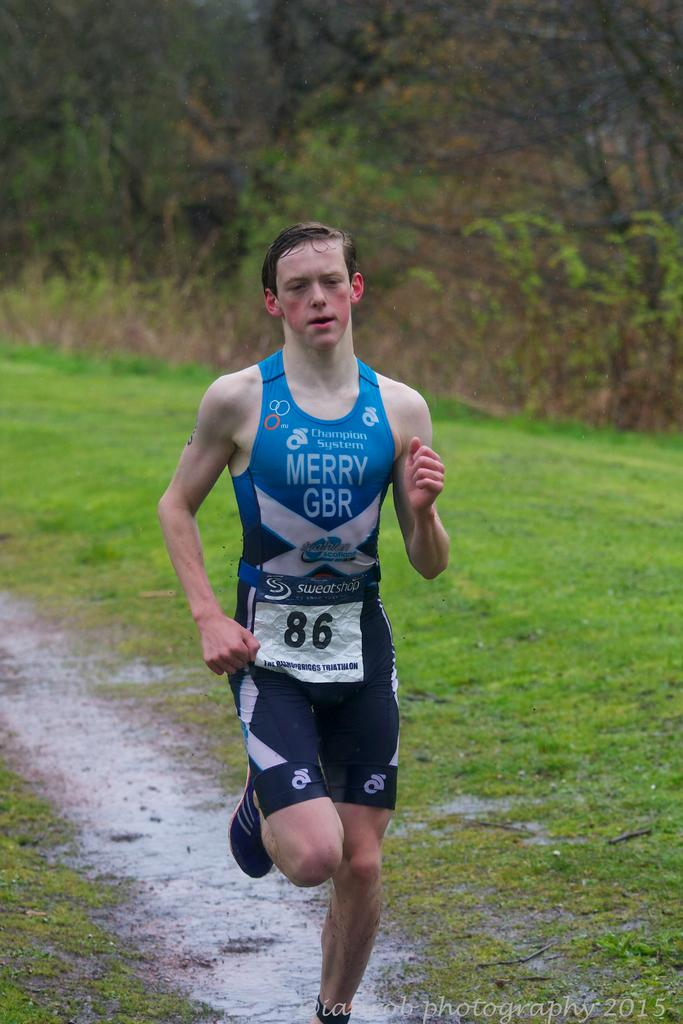<image>
Write a terse but informative summary of the picture. A man runs through the mud wearing the number 86 and with the words Merry GBR on his top 